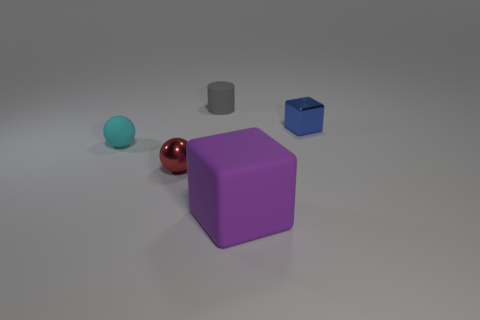Add 4 cyan matte spheres. How many objects exist? 9 Subtract all blue cubes. How many cubes are left? 1 Subtract 0 blue cylinders. How many objects are left? 5 Subtract all balls. How many objects are left? 3 Subtract all large purple cubes. Subtract all large balls. How many objects are left? 4 Add 2 small matte balls. How many small matte balls are left? 3 Add 5 large purple matte blocks. How many large purple matte blocks exist? 6 